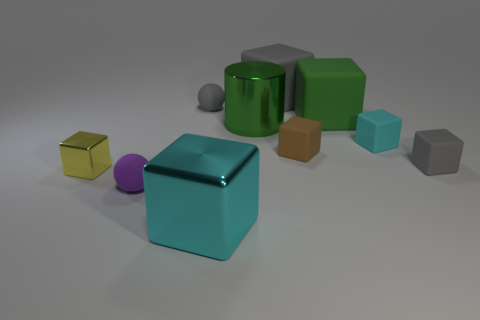The small metal object has what color?
Keep it short and to the point. Yellow. Are there any other things that have the same shape as the small brown object?
Provide a succinct answer. Yes. There is another rubber object that is the same shape as the tiny purple object; what color is it?
Your answer should be compact. Gray. Do the big green rubber object and the cyan metal thing have the same shape?
Offer a terse response. Yes. What number of cylinders are large things or small objects?
Offer a very short reply. 1. There is a cylinder that is the same material as the big cyan cube; what color is it?
Make the answer very short. Green. There is a gray block in front of the green metal cylinder; is it the same size as the green shiny cylinder?
Make the answer very short. No. Does the small cyan cube have the same material as the big block left of the big gray rubber thing?
Your answer should be very brief. No. There is a metallic cube in front of the yellow block; what is its color?
Keep it short and to the point. Cyan. Are there any tiny purple things right of the matte ball in front of the tiny cyan rubber object?
Your response must be concise. No. 